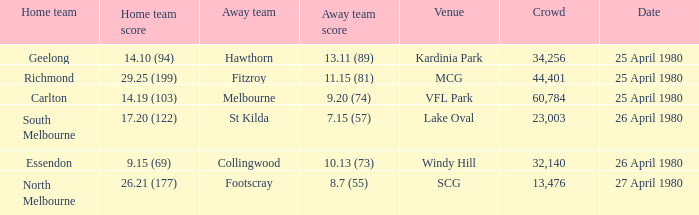On what date did the match at Lake Oval take place? 26 April 1980. 